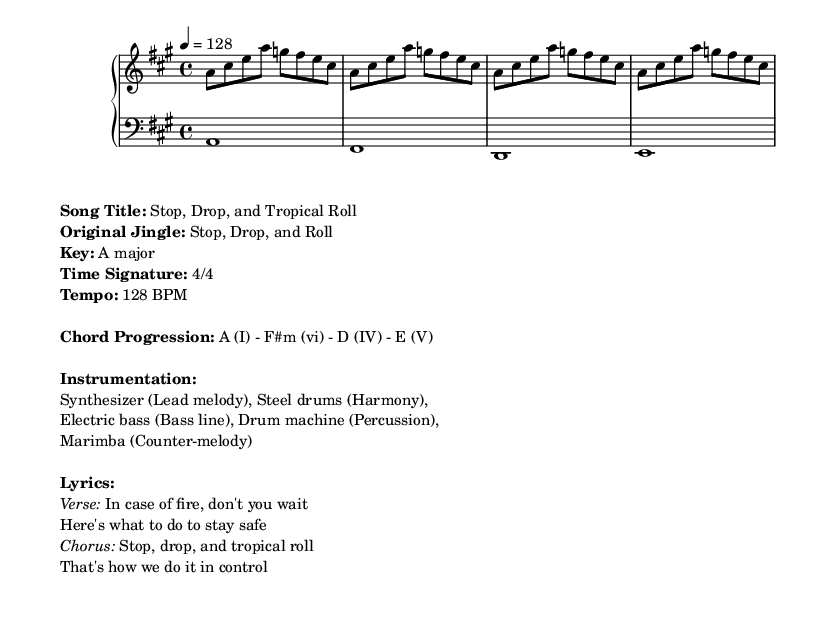What is the key of this piece? The key of the piece is indicated as A major in the markup section. The key signature with three sharps corresponds to this key.
Answer: A major What is the time signature? The time signature is shown in the music sheet as 4/4, which indicates that each measure contains four beats.
Answer: 4/4 What is the tempo of the song? The tempo is specified as 128 BPM in the markup section, indicating the speed of the music.
Answer: 128 BPM What is the primary theme of the lyrics? The lyrics emphasize fire safety, specifically instructions given during a fire emergency, which corresponds to the jingle "Stop, Drop, and Roll."
Answer: Fire safety Which chord is the tonic in this piece? The tonic is the first chord in the key of A major, which is A. The chord progression starts with A (I) and reinforces it as the foundational chord.
Answer: A What type of instruments are used in the arrangement? The instrumentation is listed in the markup and specifies multiple instruments: synthesizer, steel drums, electric bass, drum machine, and marimba, all contributing to the tropical house vibe.
Answer: Synthesizer, steel drums, electric bass, drum machine, marimba What is the significance of the title "Stop, Drop, and Tropical Roll"? The title cleverly reinterprets the classic fire safety message while incorporating a tropical house music style, making it engaging and memorable for listeners.
Answer: Playful fire safety jingle 